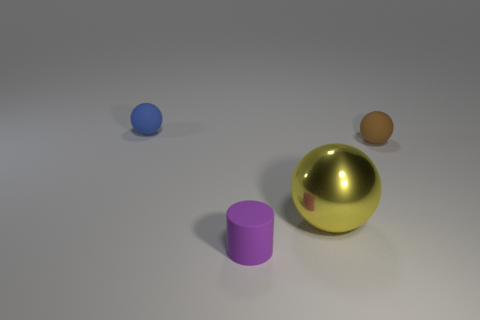What is the color of the matte sphere that is the same size as the blue matte object?
Your response must be concise. Brown. What number of cylinders are purple objects or large red metallic objects?
Make the answer very short. 1. There is a tiny blue matte object; is its shape the same as the matte object that is in front of the small brown ball?
Give a very brief answer. No. What number of purple cylinders have the same size as the brown rubber ball?
Offer a very short reply. 1. There is a small purple thing in front of the blue matte ball; does it have the same shape as the matte object that is on the right side of the big sphere?
Keep it short and to the point. No. What color is the thing behind the thing on the right side of the yellow ball?
Your answer should be very brief. Blue. There is another tiny rubber object that is the same shape as the brown rubber object; what color is it?
Offer a very short reply. Blue. Is there any other thing that has the same material as the large yellow ball?
Your response must be concise. No. What is the size of the brown matte thing that is the same shape as the tiny blue object?
Provide a succinct answer. Small. There is a small object left of the tiny purple matte object; what material is it?
Offer a terse response. Rubber. 